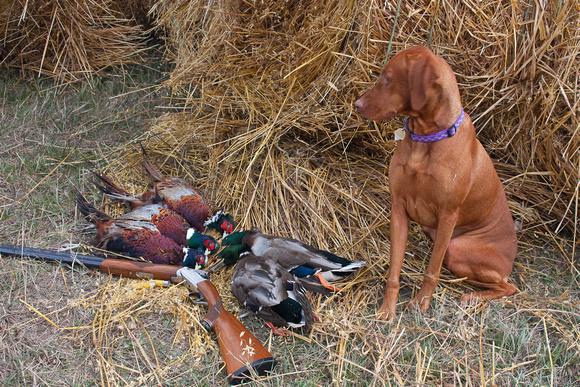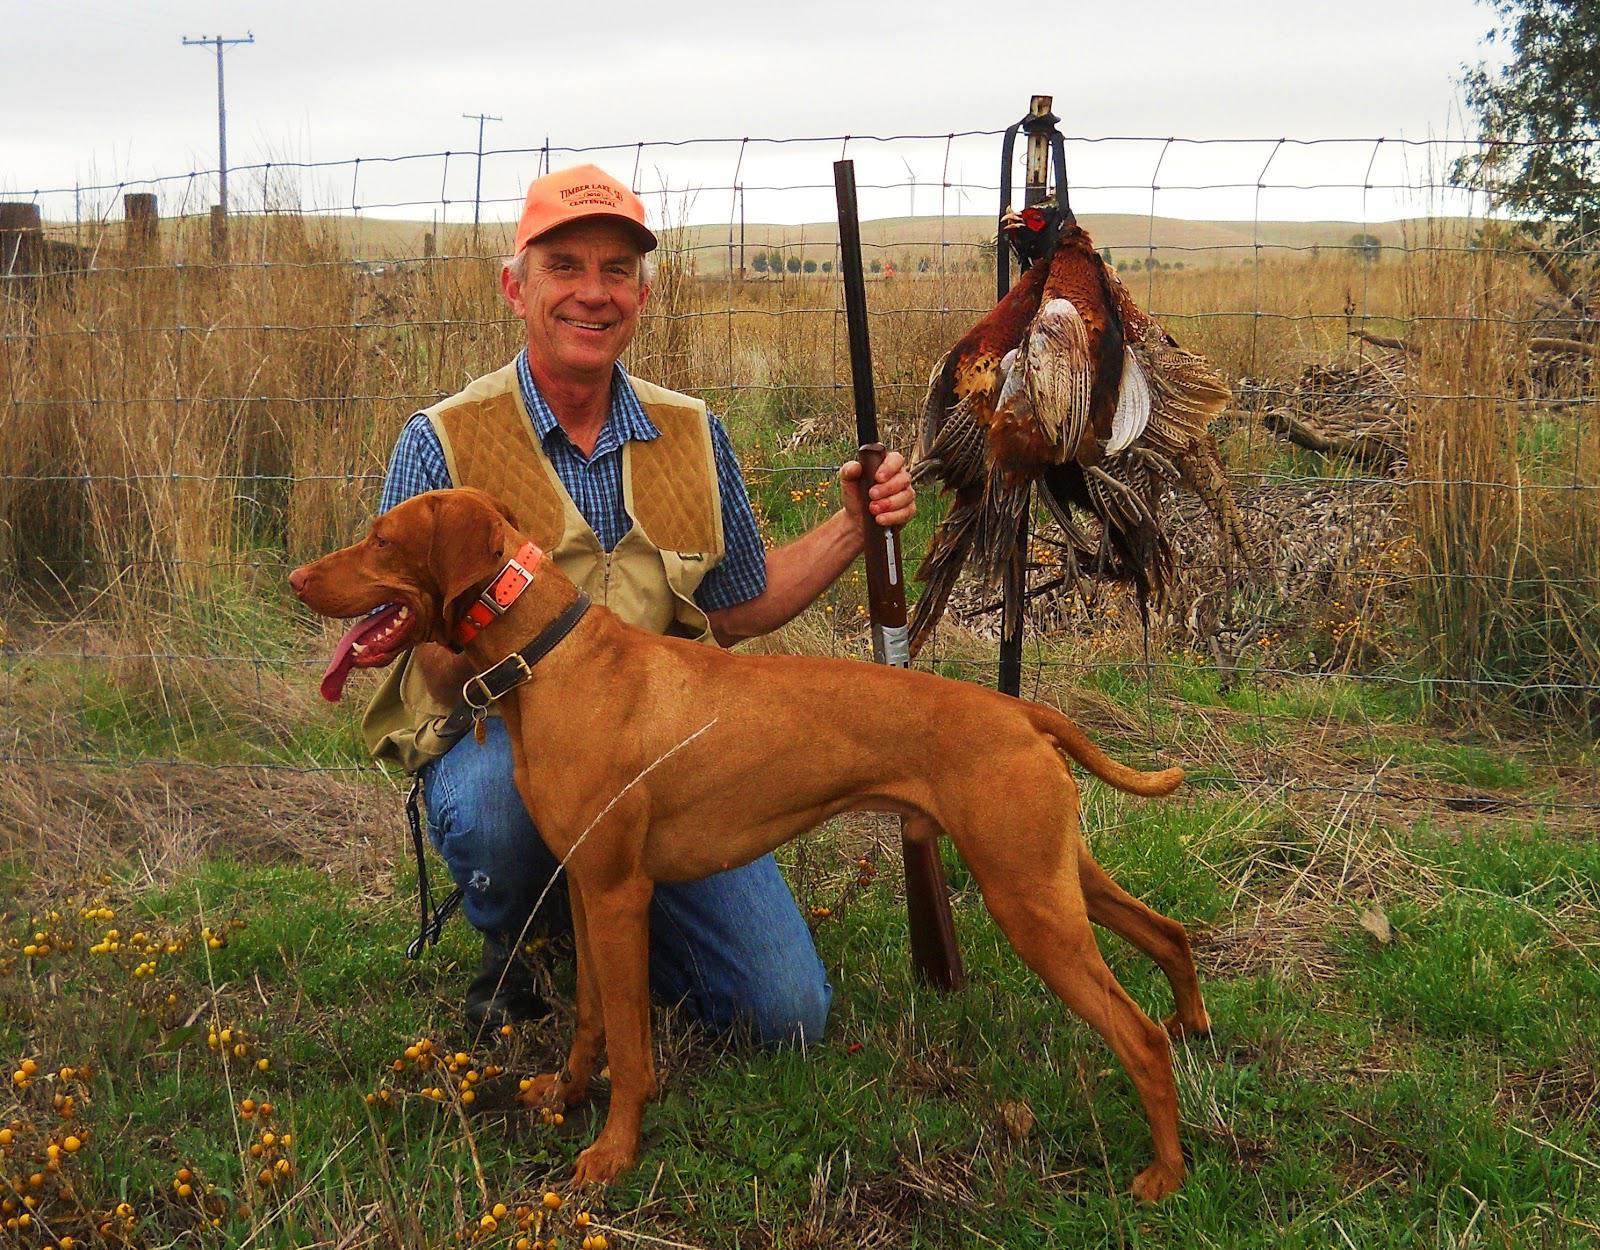The first image is the image on the left, the second image is the image on the right. For the images displayed, is the sentence "In at least one image there is a shotgun behind a dog with his tongue stuck out." factually correct? Answer yes or no. Yes. The first image is the image on the left, the second image is the image on the right. For the images shown, is this caption "A dog is laying down." true? Answer yes or no. No. 